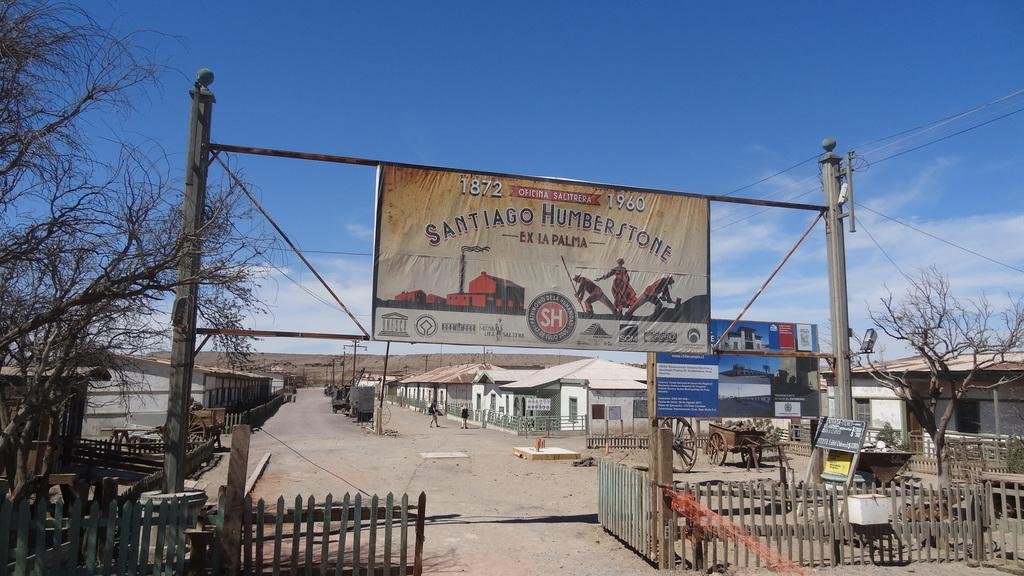<image>
Offer a succinct explanation of the picture presented. A sign saying Santiago Humberstone with the years 1872 and 1960 on it. 